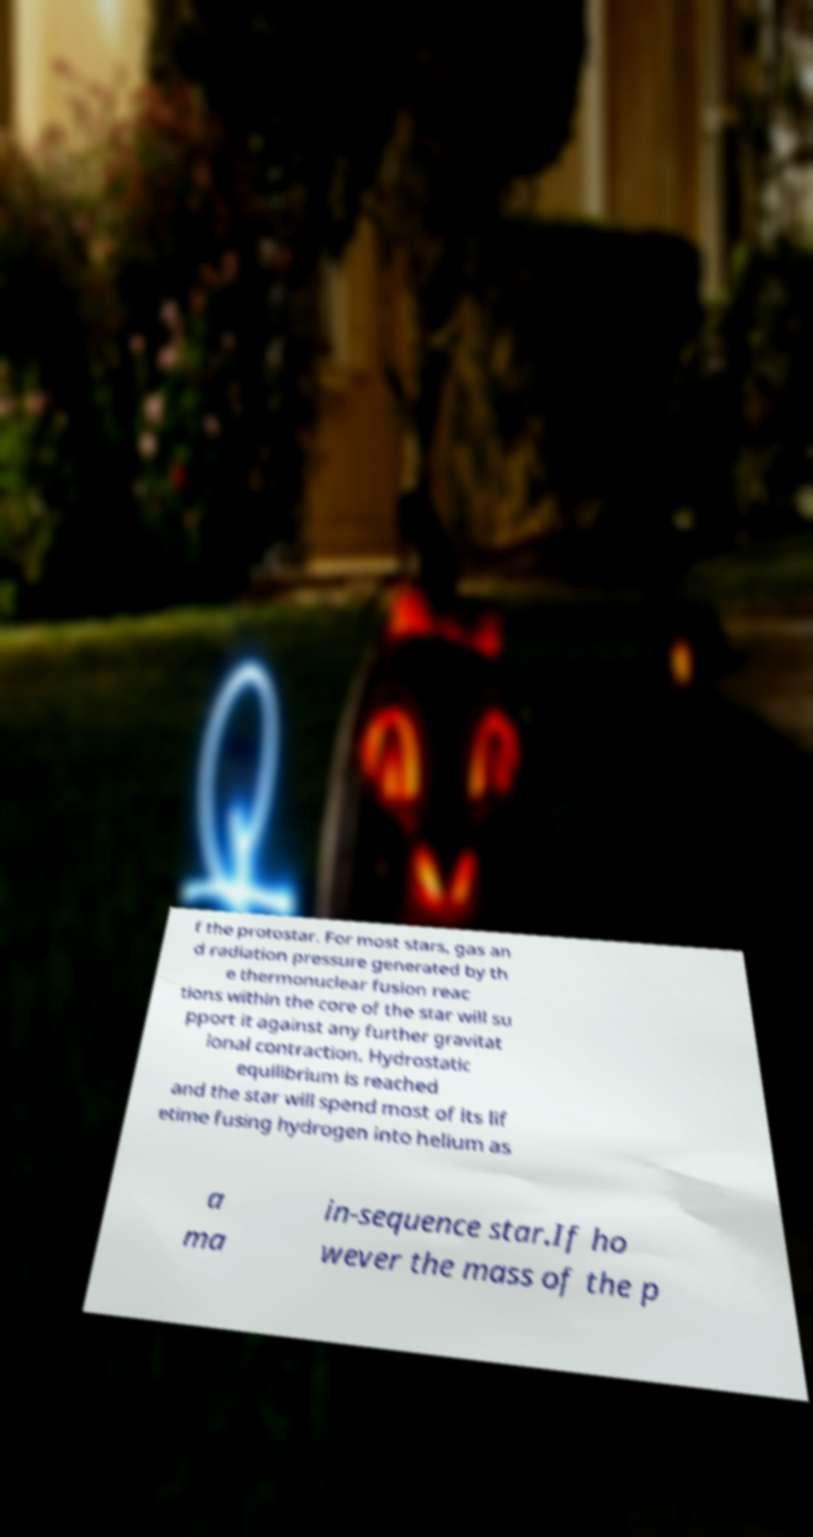Please read and relay the text visible in this image. What does it say? f the protostar. For most stars, gas an d radiation pressure generated by th e thermonuclear fusion reac tions within the core of the star will su pport it against any further gravitat ional contraction. Hydrostatic equilibrium is reached and the star will spend most of its lif etime fusing hydrogen into helium as a ma in-sequence star.If ho wever the mass of the p 